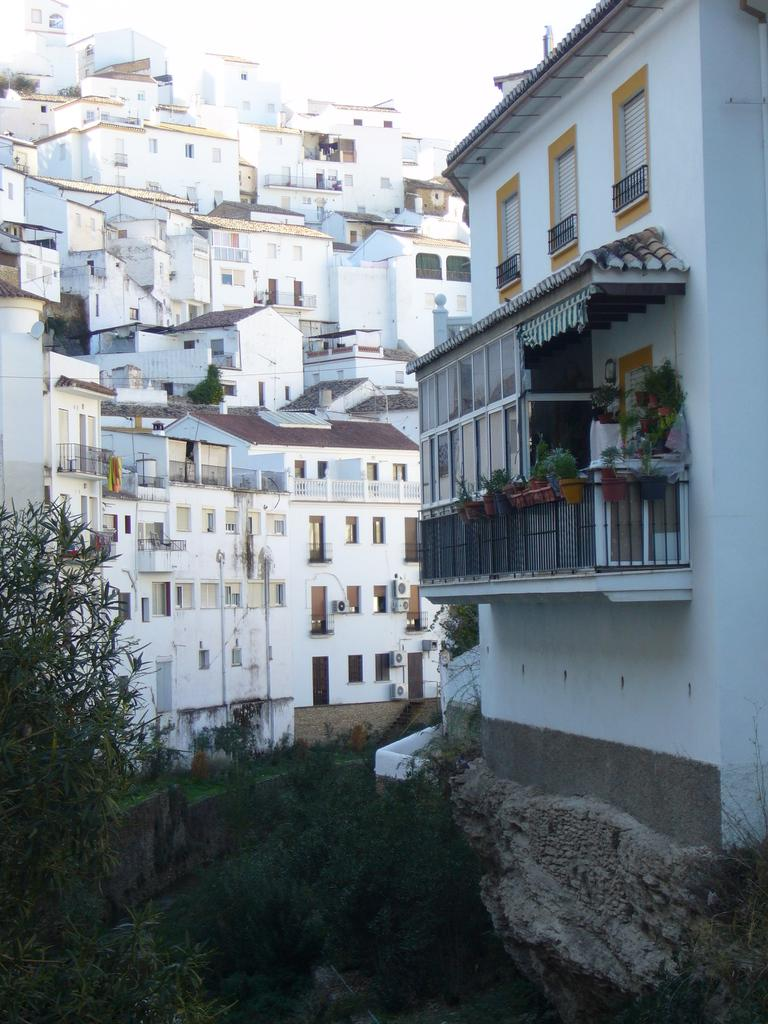What type of structures are present in the image? There are buildings in the image. What color are the buildings? The buildings are white. What can be seen in the bottom left corner of the image? There are branches in the bottom left of the image. What is visible at the top of the image? The sky is visible at the top of the image. What hobbies are the buildings participating in during the day? Buildings do not have hobbies, as they are inanimate structures. 